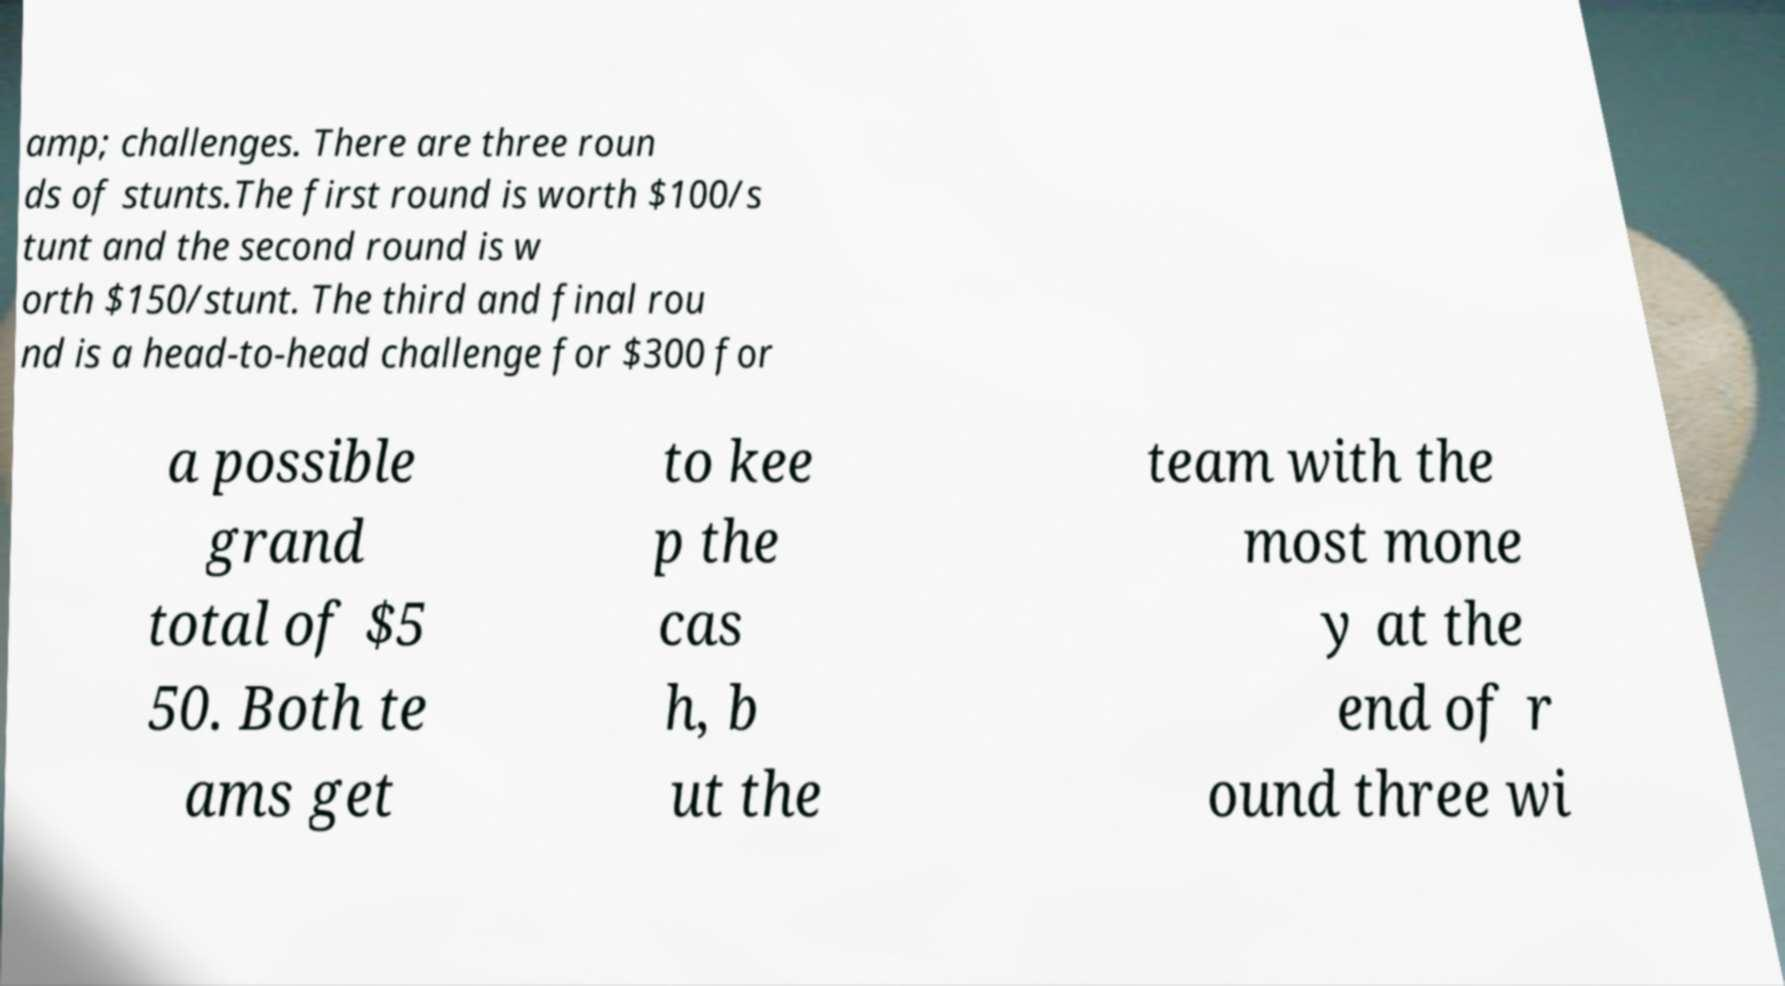I need the written content from this picture converted into text. Can you do that? amp; challenges. There are three roun ds of stunts.The first round is worth $100/s tunt and the second round is w orth $150/stunt. The third and final rou nd is a head-to-head challenge for $300 for a possible grand total of $5 50. Both te ams get to kee p the cas h, b ut the team with the most mone y at the end of r ound three wi 